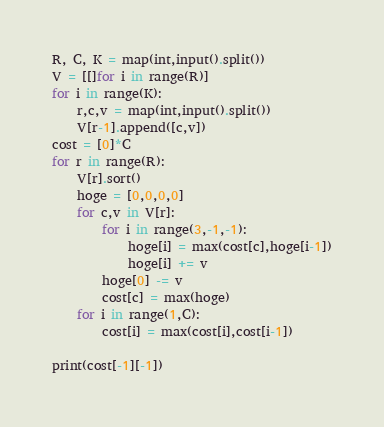Convert code to text. <code><loc_0><loc_0><loc_500><loc_500><_Python_>R, C, K = map(int,input().split())
V = [[]for i in range(R)]
for i in range(K):
    r,c,v = map(int,input().split())
    V[r-1].append([c,v])
cost = [0]*C
for r in range(R):
    V[r].sort()
    hoge = [0,0,0,0]
    for c,v in V[r]:
        for i in range(3,-1,-1):
            hoge[i] = max(cost[c],hoge[i-1])
            hoge[i] += v
        hoge[0] -= v
        cost[c] = max(hoge)
    for i in range(1,C):
        cost[i] = max(cost[i],cost[i-1])

print(cost[-1][-1]) </code> 